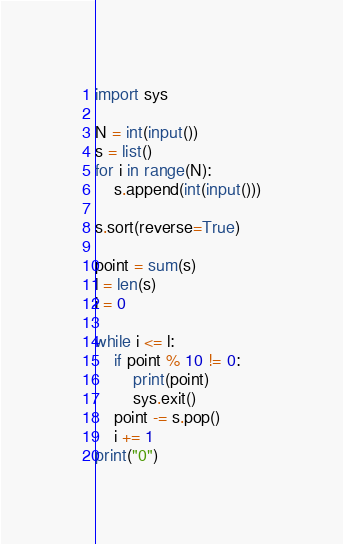<code> <loc_0><loc_0><loc_500><loc_500><_Python_>import sys

N = int(input())
s = list()
for i in range(N):
    s.append(int(input()))

s.sort(reverse=True)

point = sum(s)
l = len(s)
i = 0

while i <= l:
    if point % 10 != 0:
        print(point)
        sys.exit()
    point -= s.pop()
    i += 1
print("0")</code> 